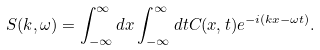<formula> <loc_0><loc_0><loc_500><loc_500>S ( k , \omega ) = \int _ { - \infty } ^ { \infty } d x \int _ { - \infty } ^ { \infty } d t C ( x , t ) e ^ { - i ( k x - \omega t ) } .</formula> 